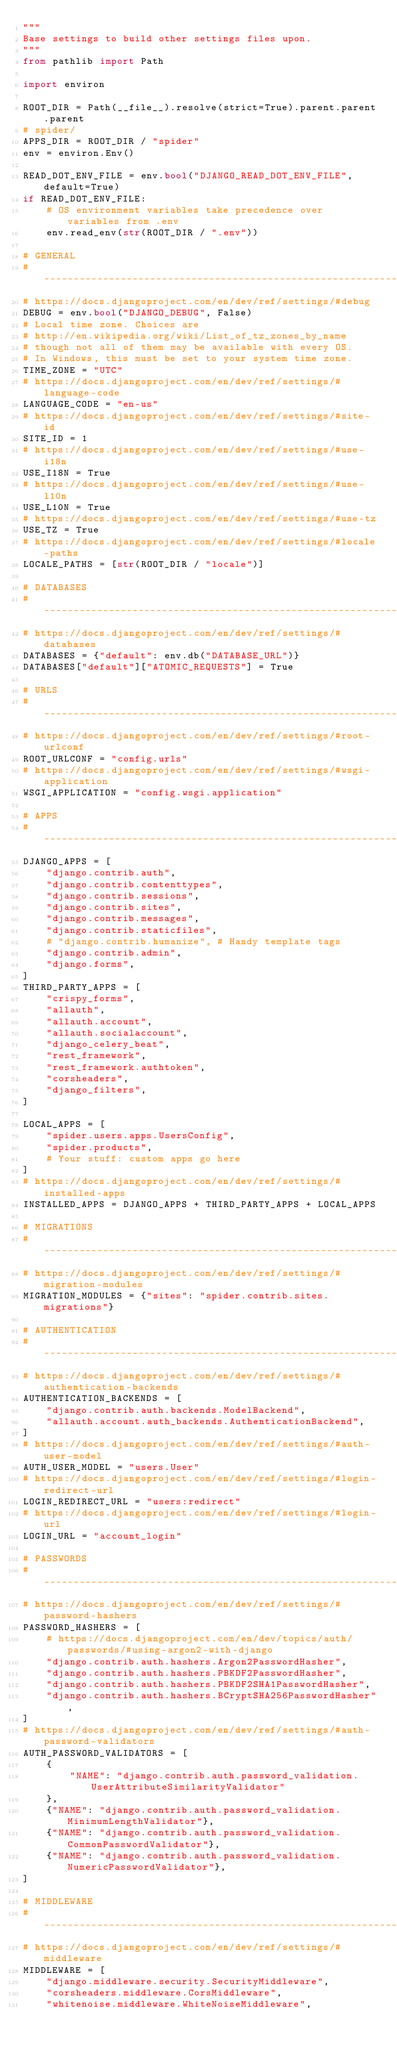Convert code to text. <code><loc_0><loc_0><loc_500><loc_500><_Python_>"""
Base settings to build other settings files upon.
"""
from pathlib import Path

import environ

ROOT_DIR = Path(__file__).resolve(strict=True).parent.parent.parent
# spider/
APPS_DIR = ROOT_DIR / "spider"
env = environ.Env()

READ_DOT_ENV_FILE = env.bool("DJANGO_READ_DOT_ENV_FILE", default=True)
if READ_DOT_ENV_FILE:
    # OS environment variables take precedence over variables from .env
    env.read_env(str(ROOT_DIR / ".env"))

# GENERAL
# ------------------------------------------------------------------------------
# https://docs.djangoproject.com/en/dev/ref/settings/#debug
DEBUG = env.bool("DJANGO_DEBUG", False)
# Local time zone. Choices are
# http://en.wikipedia.org/wiki/List_of_tz_zones_by_name
# though not all of them may be available with every OS.
# In Windows, this must be set to your system time zone.
TIME_ZONE = "UTC"
# https://docs.djangoproject.com/en/dev/ref/settings/#language-code
LANGUAGE_CODE = "en-us"
# https://docs.djangoproject.com/en/dev/ref/settings/#site-id
SITE_ID = 1
# https://docs.djangoproject.com/en/dev/ref/settings/#use-i18n
USE_I18N = True
# https://docs.djangoproject.com/en/dev/ref/settings/#use-l10n
USE_L10N = True
# https://docs.djangoproject.com/en/dev/ref/settings/#use-tz
USE_TZ = True
# https://docs.djangoproject.com/en/dev/ref/settings/#locale-paths
LOCALE_PATHS = [str(ROOT_DIR / "locale")]

# DATABASES
# ------------------------------------------------------------------------------
# https://docs.djangoproject.com/en/dev/ref/settings/#databases
DATABASES = {"default": env.db("DATABASE_URL")}
DATABASES["default"]["ATOMIC_REQUESTS"] = True

# URLS
# ------------------------------------------------------------------------------
# https://docs.djangoproject.com/en/dev/ref/settings/#root-urlconf
ROOT_URLCONF = "config.urls"
# https://docs.djangoproject.com/en/dev/ref/settings/#wsgi-application
WSGI_APPLICATION = "config.wsgi.application"

# APPS
# ------------------------------------------------------------------------------
DJANGO_APPS = [
    "django.contrib.auth",
    "django.contrib.contenttypes",
    "django.contrib.sessions",
    "django.contrib.sites",
    "django.contrib.messages",
    "django.contrib.staticfiles",
    # "django.contrib.humanize", # Handy template tags
    "django.contrib.admin",
    "django.forms",
]
THIRD_PARTY_APPS = [
    "crispy_forms",
    "allauth",
    "allauth.account",
    "allauth.socialaccount",
    "django_celery_beat",
    "rest_framework",
    "rest_framework.authtoken",
    "corsheaders",
    "django_filters",
]

LOCAL_APPS = [
    "spider.users.apps.UsersConfig",
    "spider.products",
    # Your stuff: custom apps go here
]
# https://docs.djangoproject.com/en/dev/ref/settings/#installed-apps
INSTALLED_APPS = DJANGO_APPS + THIRD_PARTY_APPS + LOCAL_APPS

# MIGRATIONS
# ------------------------------------------------------------------------------
# https://docs.djangoproject.com/en/dev/ref/settings/#migration-modules
MIGRATION_MODULES = {"sites": "spider.contrib.sites.migrations"}

# AUTHENTICATION
# ------------------------------------------------------------------------------
# https://docs.djangoproject.com/en/dev/ref/settings/#authentication-backends
AUTHENTICATION_BACKENDS = [
    "django.contrib.auth.backends.ModelBackend",
    "allauth.account.auth_backends.AuthenticationBackend",
]
# https://docs.djangoproject.com/en/dev/ref/settings/#auth-user-model
AUTH_USER_MODEL = "users.User"
# https://docs.djangoproject.com/en/dev/ref/settings/#login-redirect-url
LOGIN_REDIRECT_URL = "users:redirect"
# https://docs.djangoproject.com/en/dev/ref/settings/#login-url
LOGIN_URL = "account_login"

# PASSWORDS
# ------------------------------------------------------------------------------
# https://docs.djangoproject.com/en/dev/ref/settings/#password-hashers
PASSWORD_HASHERS = [
    # https://docs.djangoproject.com/en/dev/topics/auth/passwords/#using-argon2-with-django
    "django.contrib.auth.hashers.Argon2PasswordHasher",
    "django.contrib.auth.hashers.PBKDF2PasswordHasher",
    "django.contrib.auth.hashers.PBKDF2SHA1PasswordHasher",
    "django.contrib.auth.hashers.BCryptSHA256PasswordHasher",
]
# https://docs.djangoproject.com/en/dev/ref/settings/#auth-password-validators
AUTH_PASSWORD_VALIDATORS = [
    {
        "NAME": "django.contrib.auth.password_validation.UserAttributeSimilarityValidator"
    },
    {"NAME": "django.contrib.auth.password_validation.MinimumLengthValidator"},
    {"NAME": "django.contrib.auth.password_validation.CommonPasswordValidator"},
    {"NAME": "django.contrib.auth.password_validation.NumericPasswordValidator"},
]

# MIDDLEWARE
# ------------------------------------------------------------------------------
# https://docs.djangoproject.com/en/dev/ref/settings/#middleware
MIDDLEWARE = [
    "django.middleware.security.SecurityMiddleware",
    "corsheaders.middleware.CorsMiddleware",
    "whitenoise.middleware.WhiteNoiseMiddleware",</code> 